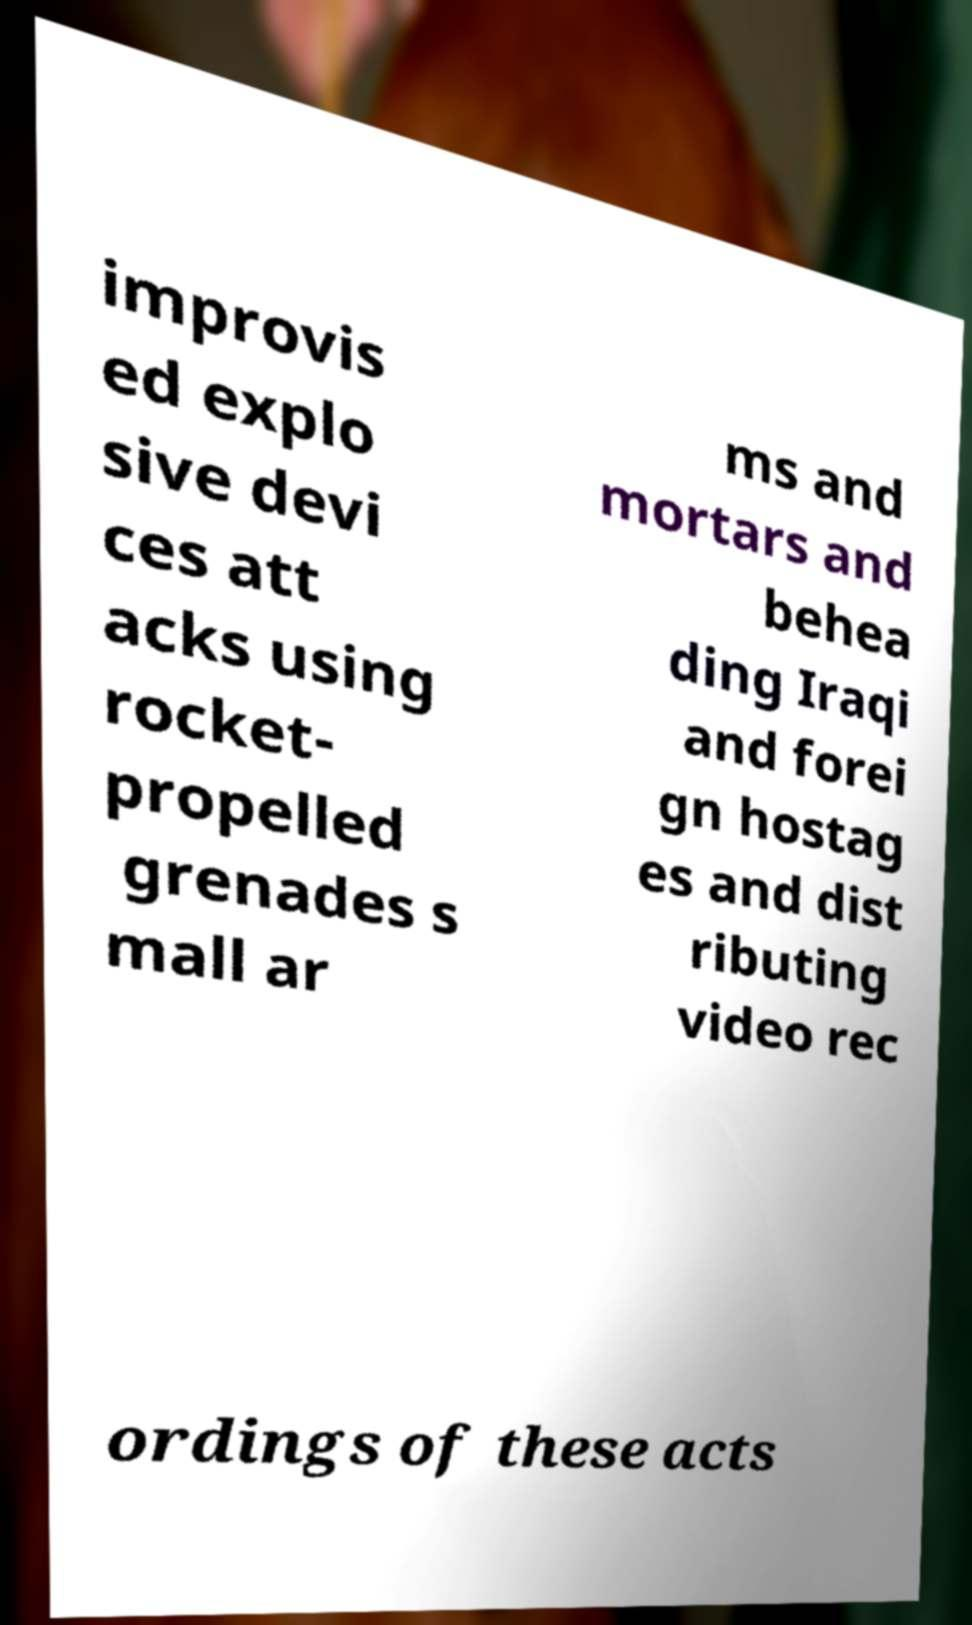I need the written content from this picture converted into text. Can you do that? improvis ed explo sive devi ces att acks using rocket- propelled grenades s mall ar ms and mortars and behea ding Iraqi and forei gn hostag es and dist ributing video rec ordings of these acts 